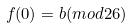Convert formula to latex. <formula><loc_0><loc_0><loc_500><loc_500>f ( 0 ) = b ( m o d 2 6 )</formula> 